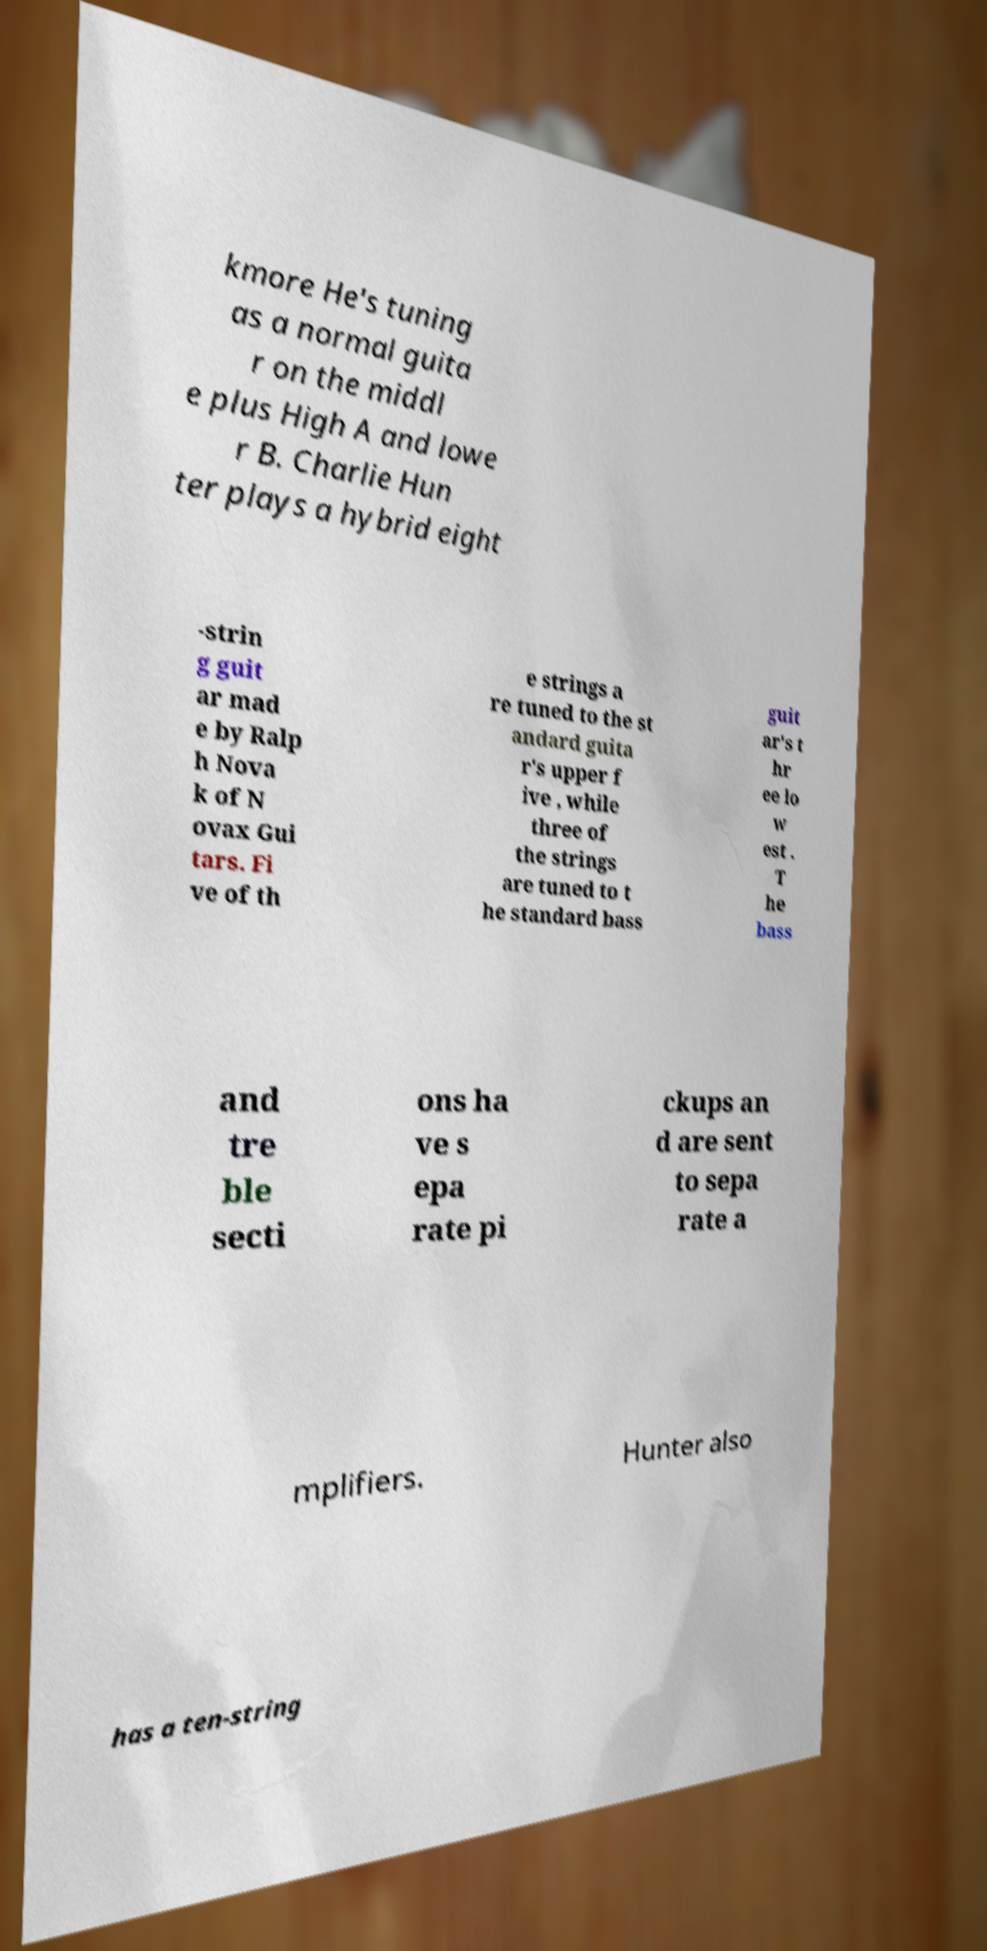Could you assist in decoding the text presented in this image and type it out clearly? kmore He's tuning as a normal guita r on the middl e plus High A and lowe r B. Charlie Hun ter plays a hybrid eight -strin g guit ar mad e by Ralp h Nova k of N ovax Gui tars. Fi ve of th e strings a re tuned to the st andard guita r's upper f ive , while three of the strings are tuned to t he standard bass guit ar's t hr ee lo w est . T he bass and tre ble secti ons ha ve s epa rate pi ckups an d are sent to sepa rate a mplifiers. Hunter also has a ten-string 